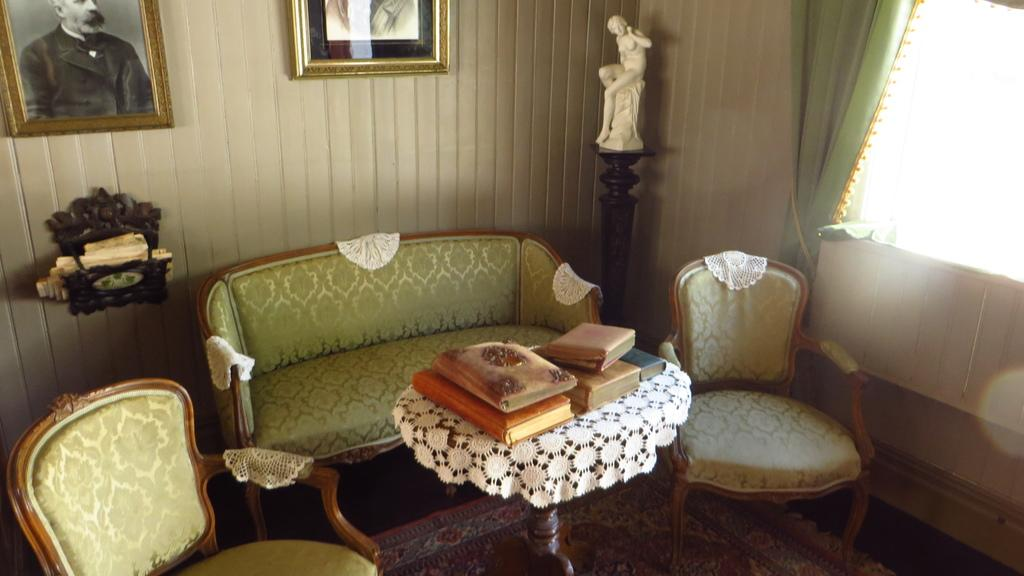What type of room is depicted in the image? The image depicts a living room. What furniture is present in the living room? There is a couch and a chair in the living room. What items can be found on the table in the living room? There are books on a table in the living room. What type of decoration is present in the living room? A sculpture is present in the living room. What is attached to the wall in the living room? There is a frame attached to the wall in the living room. What type of window treatment is present in the living room? There is a curtain in the living room. What architectural feature is present in the living room? There is a window in the living room. What flavor of pancake is being served on the couch in the image? There is no pancake present in the image, and therefore no flavor can be determined. What type of pen is being used to write on the curtain in the image? There is no pen or writing present on the curtain in the image. 